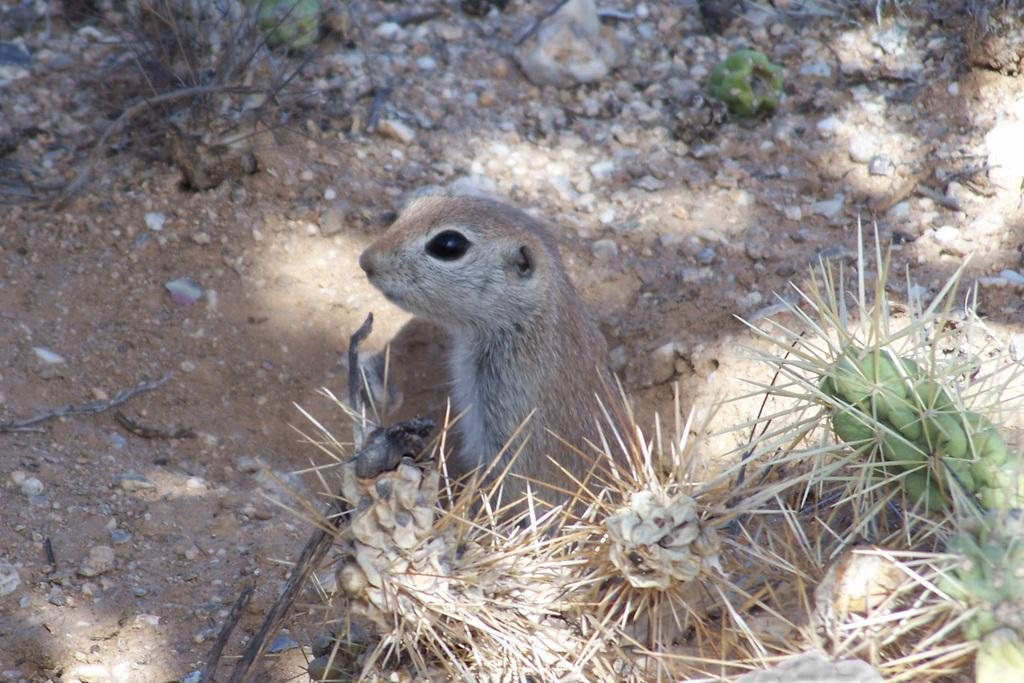What type of animal is present in the image? There is a squirrel in the image. What else can be seen in the image besides the squirrel? There are small stones in the image. What country is the squirrel from in the image? The image does not provide information about the squirrel's country of origin. 